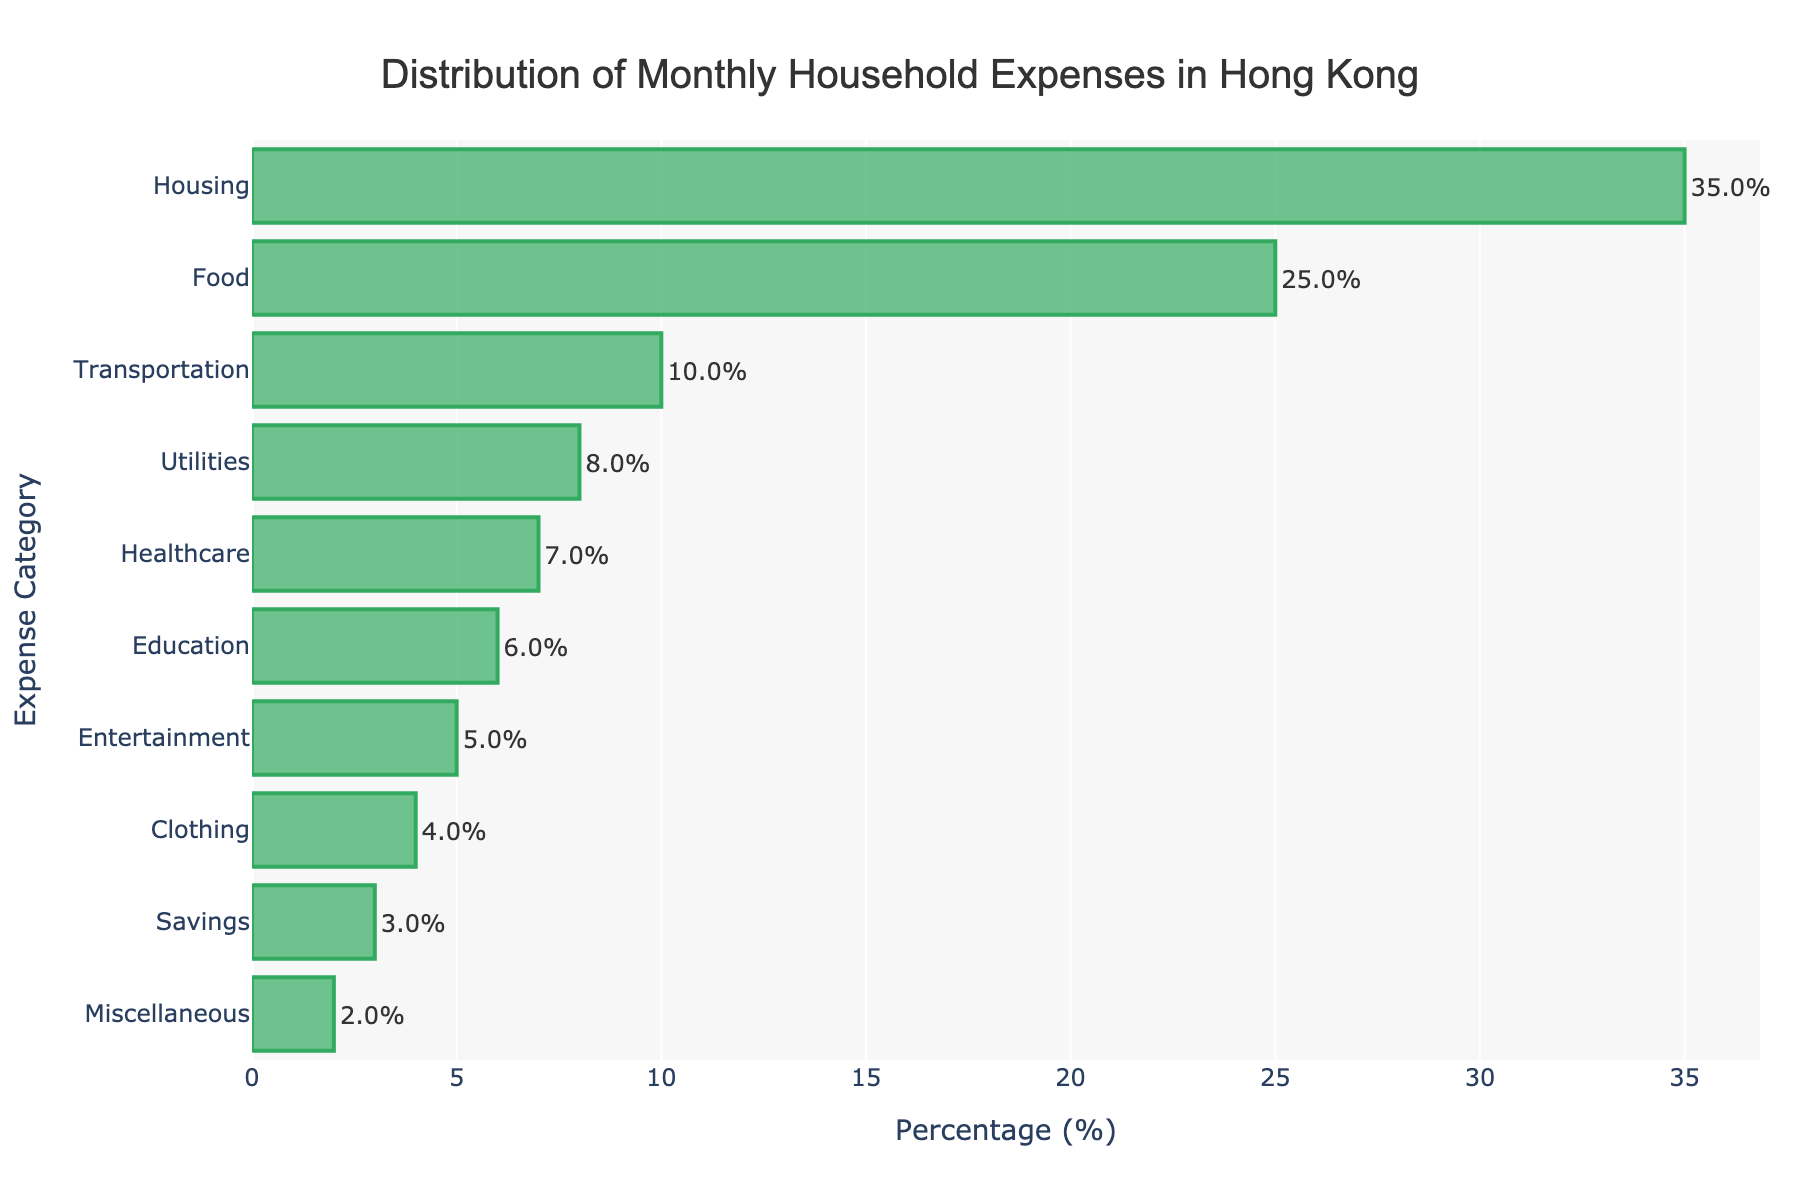What category has the highest monthly household expense percentage? The highest bar in the figure represents the category with the highest percentage. It is labeled as 'Housing'.
Answer: Housing What is the overall percentage of expenses on Food and Transportation combined? The percentage for Food is 25%, and for Transportation, it is 10%. Summing them gives 25% + 10% = 35%.
Answer: 35% Which category has a lower household expense percentage: Clothing or Entertainment? Comparing the lengths of the bars for Clothing and Entertainment, Clothing has a percentage of 4%, which is less than Entertainment's 5%.
Answer: Clothing How much more is spent on Healthcare than on Savings? The bar for Healthcare shows 7%, and the bar for Savings shows 3%. The difference is 7% - 3% = 4%.
Answer: 4% What is the average percentage spent on Utilities, Healthcare, and Education? Add the percentages of Utilities (8%), Healthcare (7%), and Education (6%) and divide by 3. The sum is 8% + 7% + 6% = 21%, and the average is 21% / 3 = 7%.
Answer: 7% Which expense category has the smallest percentage? The smallest bar represents the category with the lowest percentage, which is 'Miscellaneous' with 2%.
Answer: Miscellaneous How much more is spent on Housing compared to any category with the lowest expenditure? The highest expenditure, Housing, is 35%, and the lowest, Miscellaneous, is 2%. The difference is 35% - 2% = 33%.
Answer: 33% If total monthly expenses were $4000, how much would be allocated to Food? With Food accounting for 25%, multiply 4000 by 0.25. The calculation is 4000 * 0.25 = $1000.
Answer: $1000 Is the percentage of Education expenses equal to more, or less than Transportation? The bar for Education represents 6%, and Transportation represents 10%. 6% is less than 10%.
Answer: Less What is the percentage sum of all categories excluding Housing and Food? Sum the percentages of all categories excluding Housing (35%) and Food (25%): 10% + 8% + 7% + 6% + 5% + 4% + 3% + 2% = 45%.
Answer: 45% 